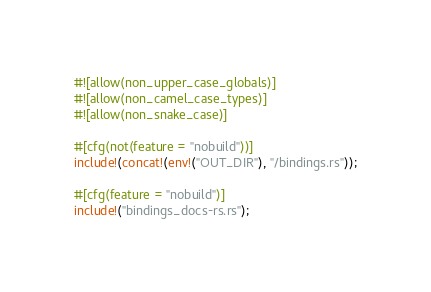Convert code to text. <code><loc_0><loc_0><loc_500><loc_500><_Rust_>#![allow(non_upper_case_globals)]
#![allow(non_camel_case_types)]
#![allow(non_snake_case)]

#[cfg(not(feature = "nobuild"))]
include!(concat!(env!("OUT_DIR"), "/bindings.rs"));

#[cfg(feature = "nobuild")]
include!("bindings_docs-rs.rs");
</code> 